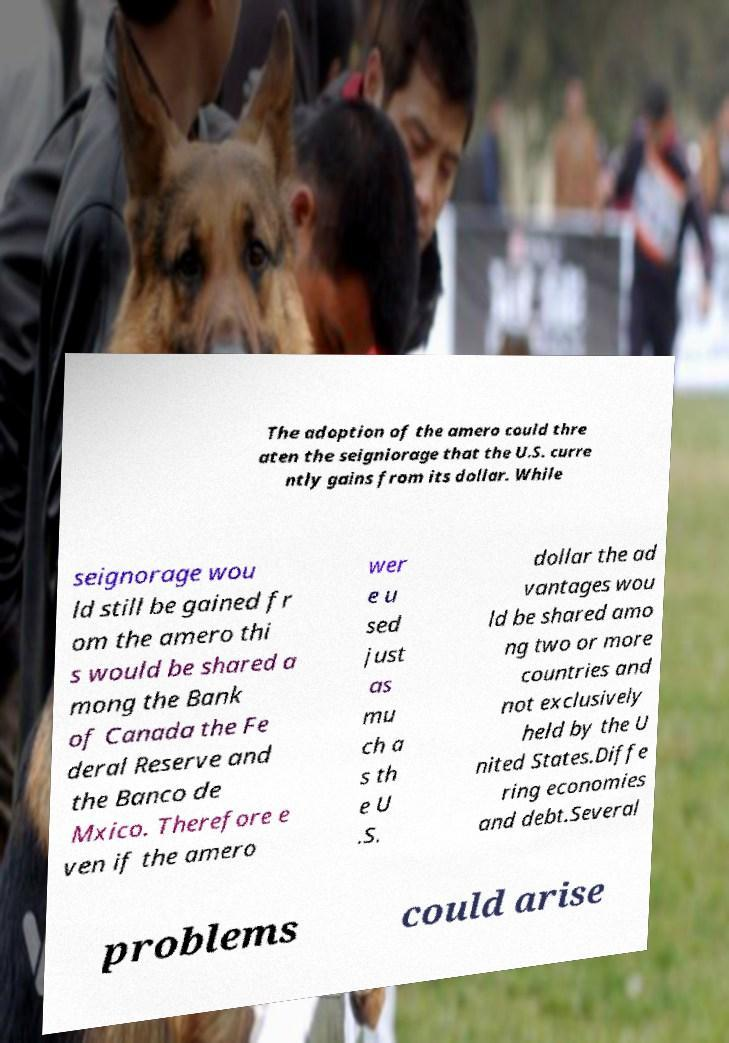What messages or text are displayed in this image? I need them in a readable, typed format. The adoption of the amero could thre aten the seigniorage that the U.S. curre ntly gains from its dollar. While seignorage wou ld still be gained fr om the amero thi s would be shared a mong the Bank of Canada the Fe deral Reserve and the Banco de Mxico. Therefore e ven if the amero wer e u sed just as mu ch a s th e U .S. dollar the ad vantages wou ld be shared amo ng two or more countries and not exclusively held by the U nited States.Diffe ring economies and debt.Several problems could arise 